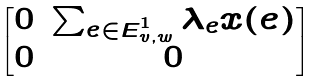<formula> <loc_0><loc_0><loc_500><loc_500>\begin{bmatrix} 0 & \sum _ { e \in E ^ { 1 } _ { v , w } } \lambda _ { e } x ( e ) \\ 0 & 0 \end{bmatrix}</formula> 